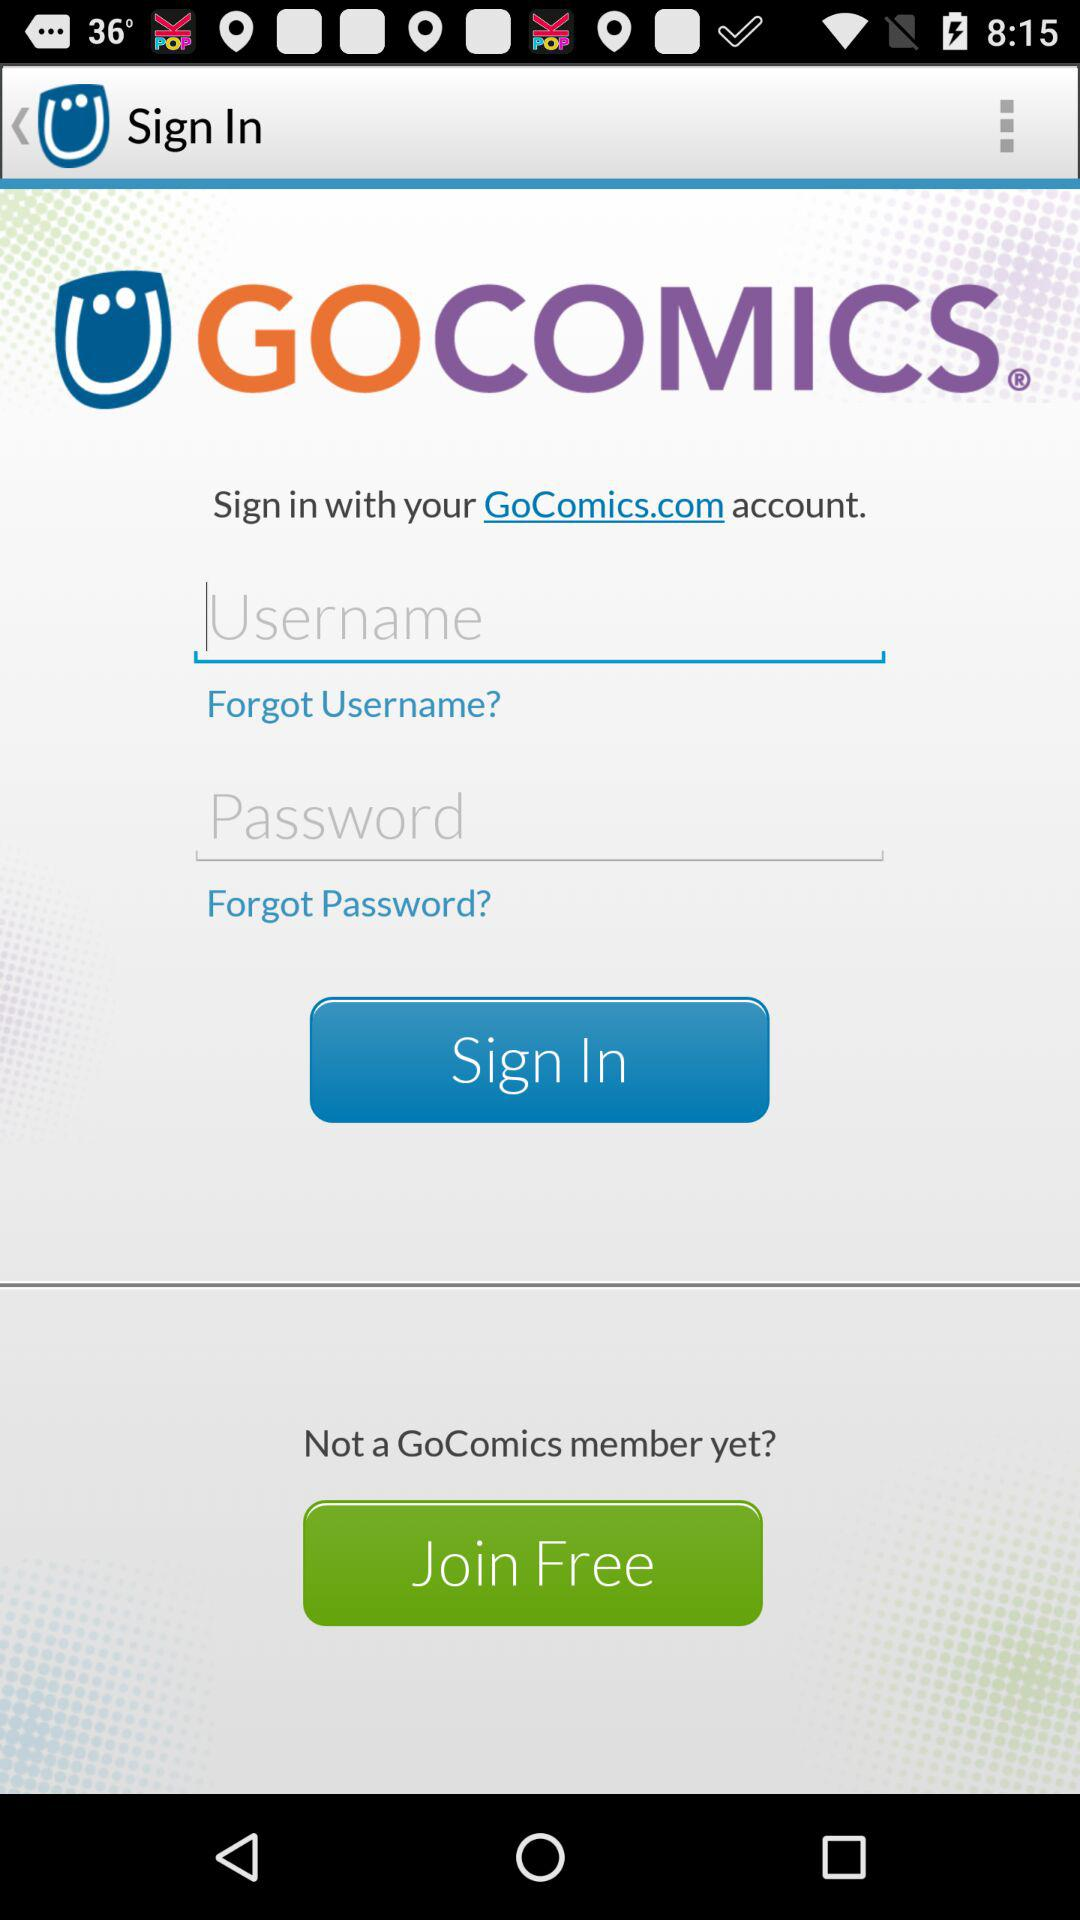How many characters are required for the password?
When the provided information is insufficient, respond with <no answer>. <no answer> 